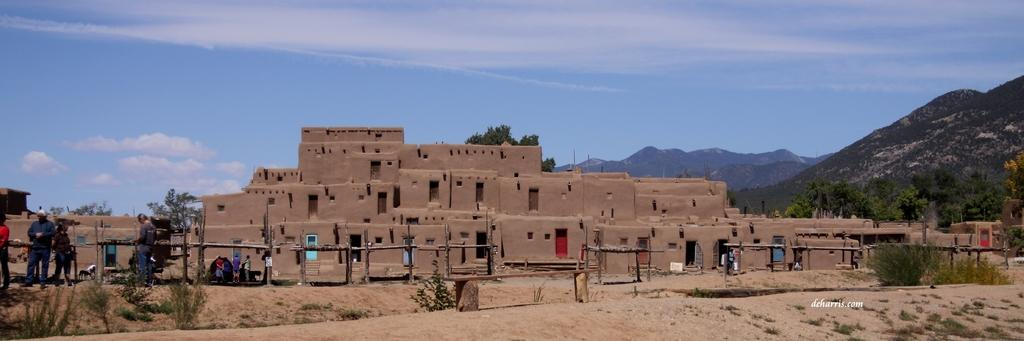What type of natural environment is visible in the image? Grass, plants, trees, and mountains are visible in the image, indicating a natural environment. What type of structures can be seen in the image? Buildings are visible in the image. What is the weather like in the image? The presence of clouds suggests that the weather might be partly cloudy. Can you describe the sky in the image? The sky is visible in the image. How many people are present in the image? There are people in the image. What color are the toes of the person in the image? There are no visible toes in the image, as the people are not shown in a way that reveals their feet. What type of fruit is being carried in a basket by one of the people in the image? There is no basket or fruit present in the image. 